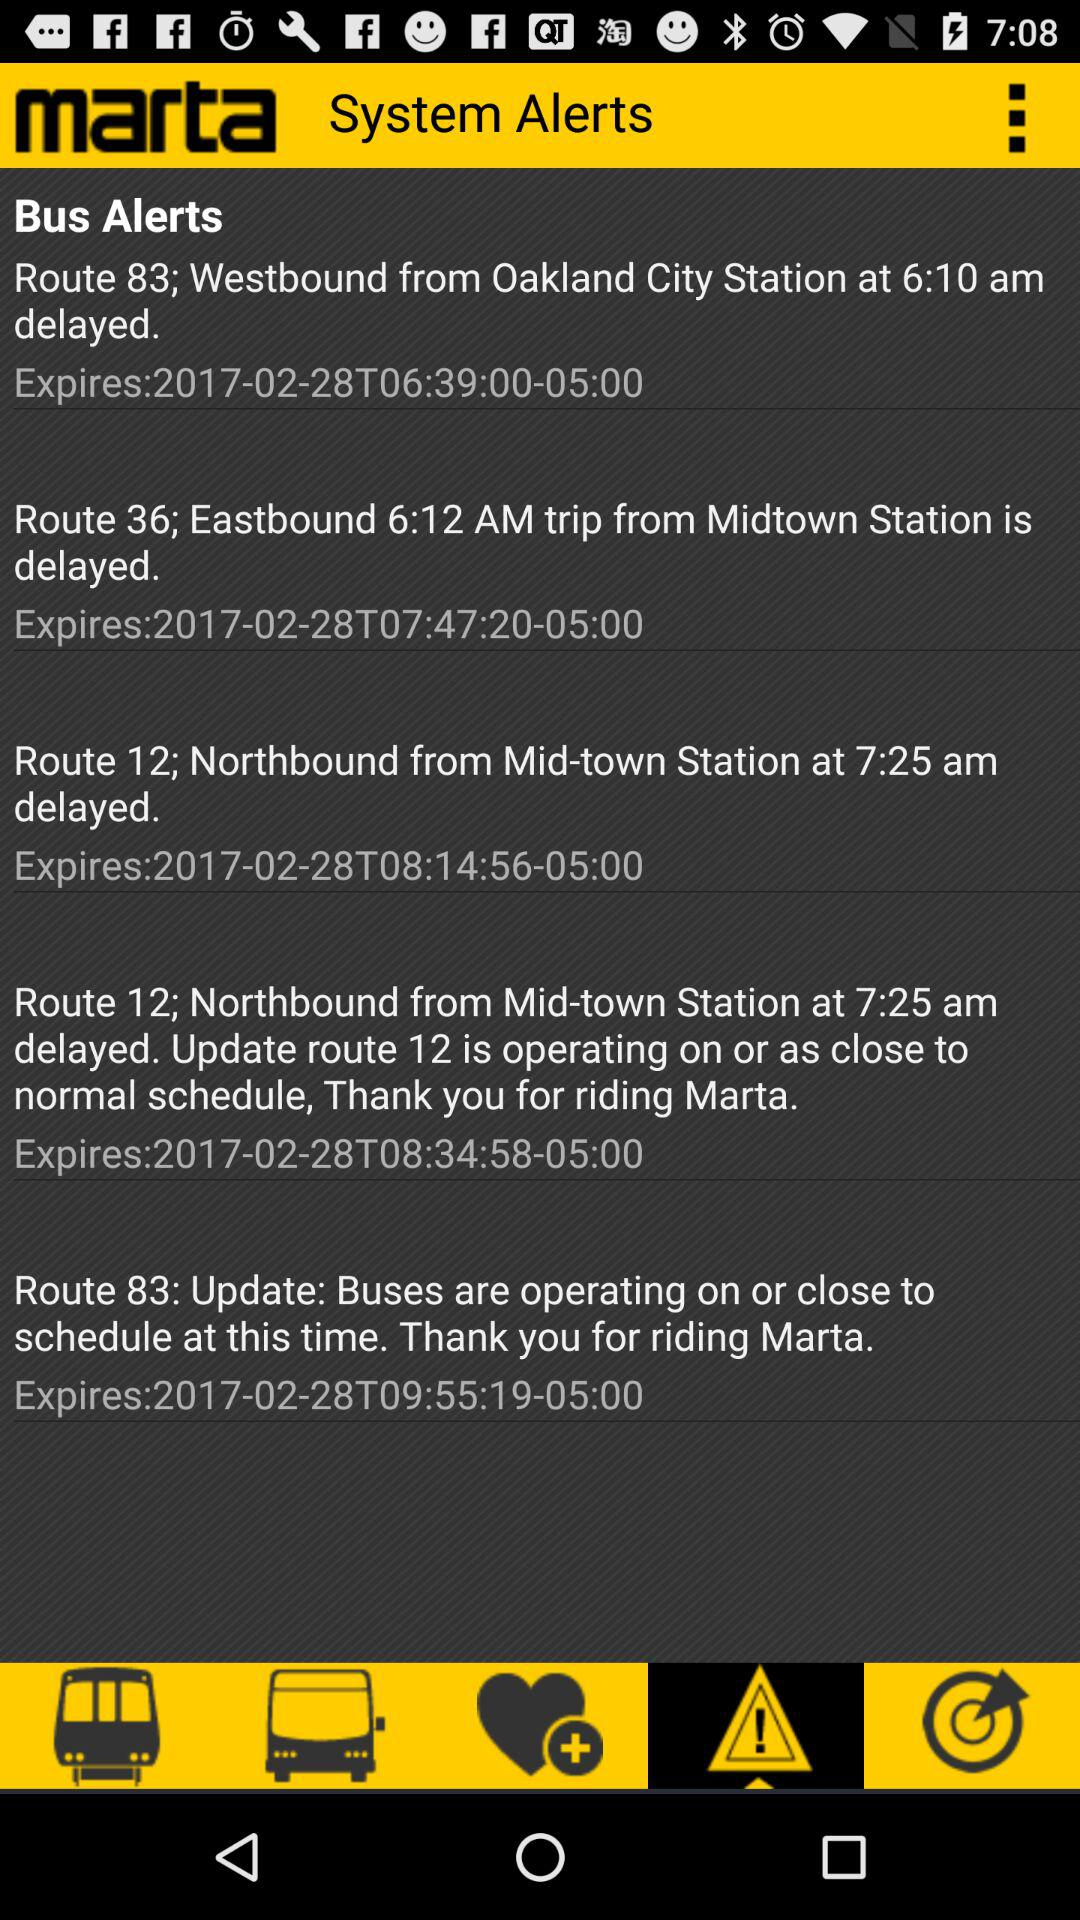What is the update for Route 83? The update for Route 83 is "Buses are operating on or close to schedule at this time. Thank you for riding Marta". 